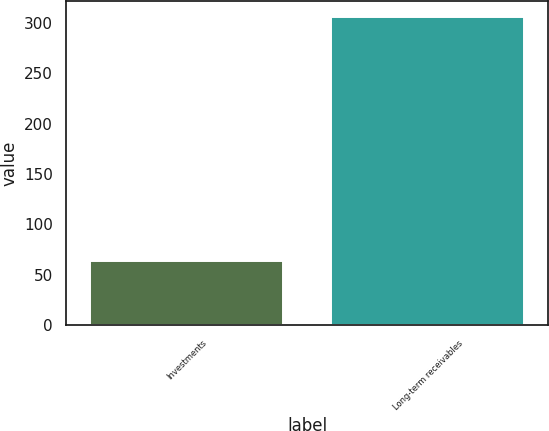<chart> <loc_0><loc_0><loc_500><loc_500><bar_chart><fcel>Investments<fcel>Long-term receivables<nl><fcel>64<fcel>306<nl></chart> 